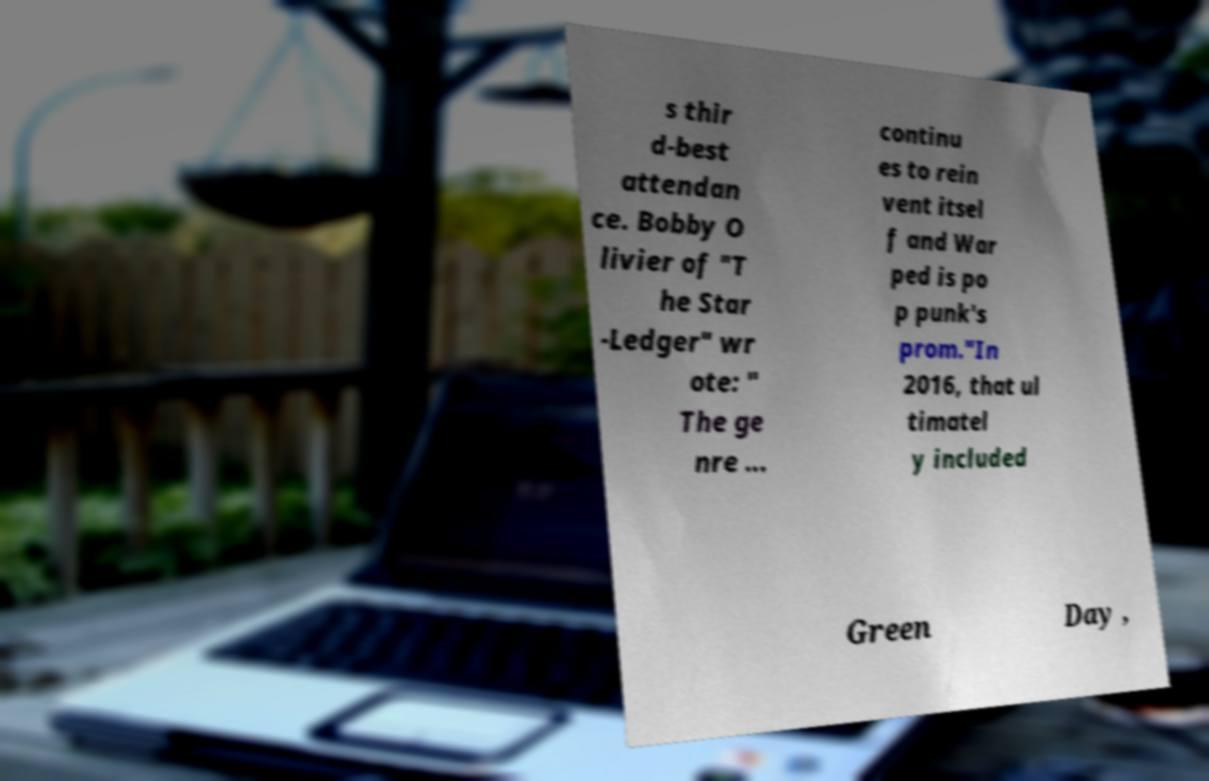What messages or text are displayed in this image? I need them in a readable, typed format. s thir d-best attendan ce. Bobby O livier of "T he Star -Ledger" wr ote: " The ge nre ... continu es to rein vent itsel f and War ped is po p punk's prom."In 2016, that ul timatel y included Green Day , 